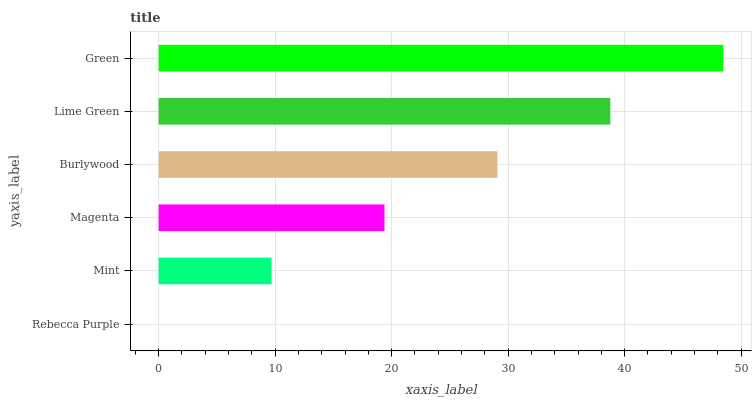Is Rebecca Purple the minimum?
Answer yes or no. Yes. Is Green the maximum?
Answer yes or no. Yes. Is Mint the minimum?
Answer yes or no. No. Is Mint the maximum?
Answer yes or no. No. Is Mint greater than Rebecca Purple?
Answer yes or no. Yes. Is Rebecca Purple less than Mint?
Answer yes or no. Yes. Is Rebecca Purple greater than Mint?
Answer yes or no. No. Is Mint less than Rebecca Purple?
Answer yes or no. No. Is Burlywood the high median?
Answer yes or no. Yes. Is Magenta the low median?
Answer yes or no. Yes. Is Green the high median?
Answer yes or no. No. Is Green the low median?
Answer yes or no. No. 